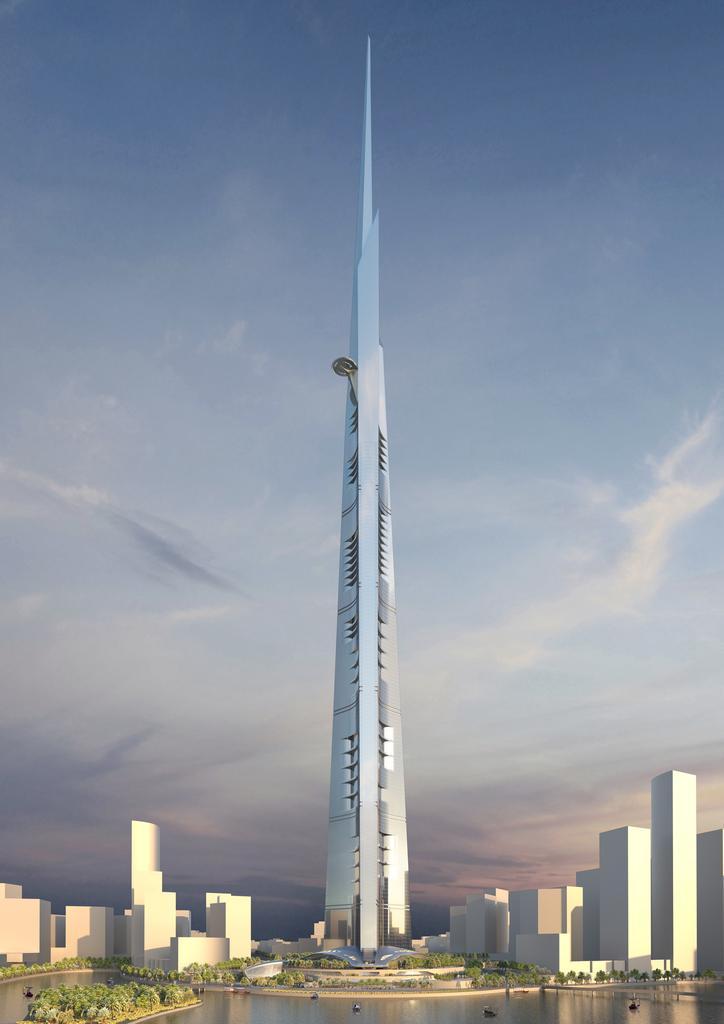Can you describe this image briefly? In the image there is a tallest tower, around that tower there are few plants and water surface. 